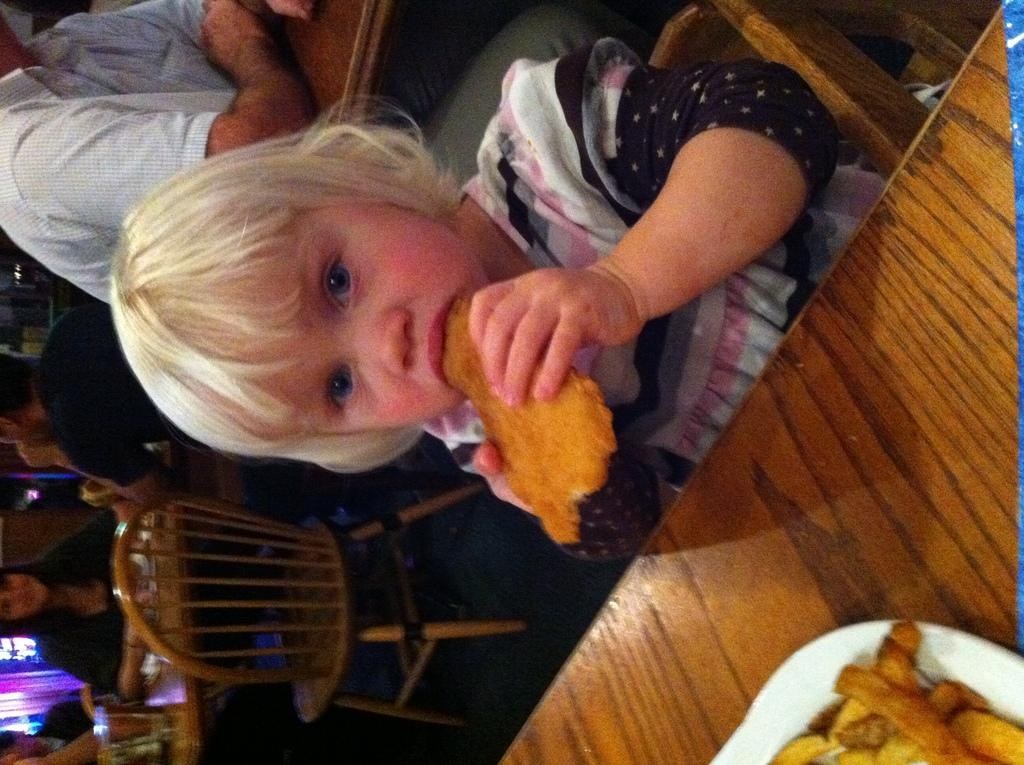What is the kid doing in the image? The kid is sitting on a chair and eating food. What is the kid using to eat the food? There is a plate on the table with food on it. What else can be seen on the table? There is a table in the image. What is visible in the background of the image? In the background, there are people, chairs, and tables. What type of wax is being used to create the mask on the kid's face in the image? There is no mask or wax present in the image; the kid is simply eating food. 